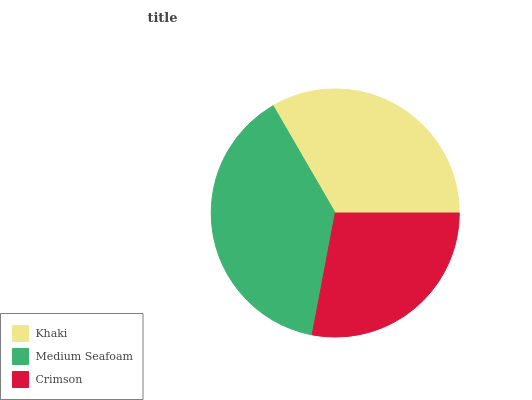Is Crimson the minimum?
Answer yes or no. Yes. Is Medium Seafoam the maximum?
Answer yes or no. Yes. Is Medium Seafoam the minimum?
Answer yes or no. No. Is Crimson the maximum?
Answer yes or no. No. Is Medium Seafoam greater than Crimson?
Answer yes or no. Yes. Is Crimson less than Medium Seafoam?
Answer yes or no. Yes. Is Crimson greater than Medium Seafoam?
Answer yes or no. No. Is Medium Seafoam less than Crimson?
Answer yes or no. No. Is Khaki the high median?
Answer yes or no. Yes. Is Khaki the low median?
Answer yes or no. Yes. Is Medium Seafoam the high median?
Answer yes or no. No. Is Crimson the low median?
Answer yes or no. No. 